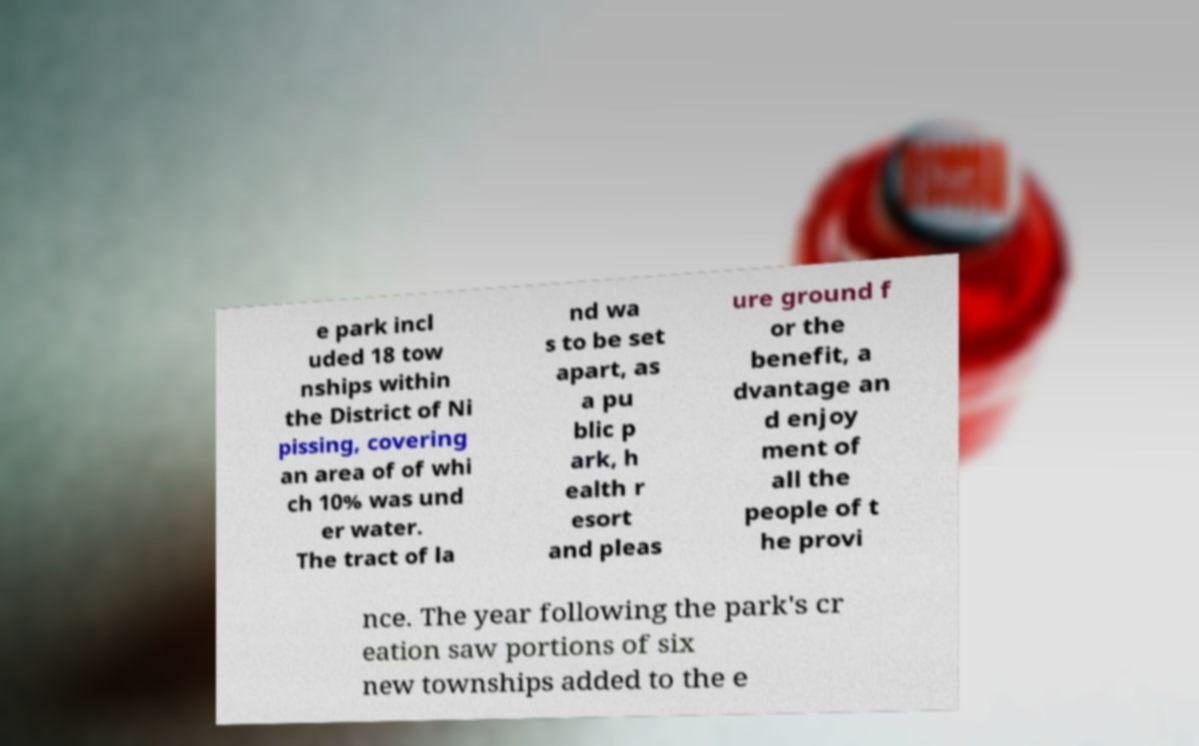Please read and relay the text visible in this image. What does it say? e park incl uded 18 tow nships within the District of Ni pissing, covering an area of of whi ch 10% was und er water. The tract of la nd wa s to be set apart, as a pu blic p ark, h ealth r esort and pleas ure ground f or the benefit, a dvantage an d enjoy ment of all the people of t he provi nce. The year following the park's cr eation saw portions of six new townships added to the e 